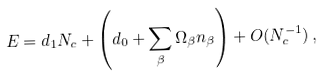Convert formula to latex. <formula><loc_0><loc_0><loc_500><loc_500>E = d _ { 1 } N _ { c } + \left ( d _ { 0 } + \sum _ { \beta } \Omega _ { \beta } n _ { \beta } \right ) + O ( N _ { c } ^ { - 1 } ) \, ,</formula> 